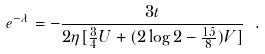<formula> <loc_0><loc_0><loc_500><loc_500>e ^ { - \lambda } = - \frac { 3 t } { 2 \eta [ \frac { 3 } { 4 } U + ( 2 \log 2 - \frac { 1 5 } { 8 } ) V ] } \ .</formula> 